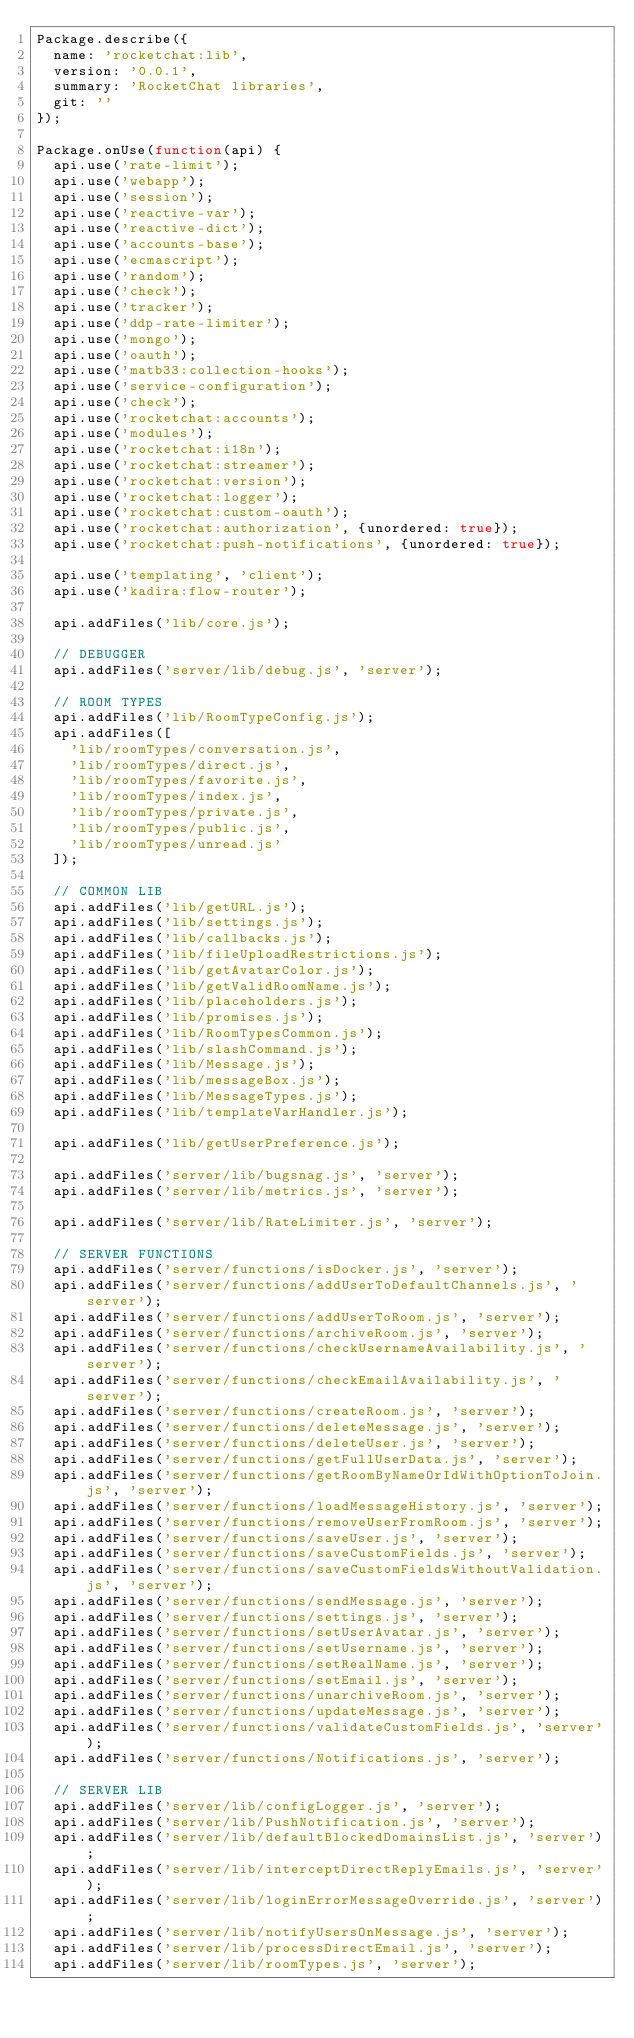Convert code to text. <code><loc_0><loc_0><loc_500><loc_500><_JavaScript_>Package.describe({
	name: 'rocketchat:lib',
	version: '0.0.1',
	summary: 'RocketChat libraries',
	git: ''
});

Package.onUse(function(api) {
	api.use('rate-limit');
	api.use('webapp');
	api.use('session');
	api.use('reactive-var');
	api.use('reactive-dict');
	api.use('accounts-base');
	api.use('ecmascript');
	api.use('random');
	api.use('check');
	api.use('tracker');
	api.use('ddp-rate-limiter');
	api.use('mongo');
	api.use('oauth');
	api.use('matb33:collection-hooks');
	api.use('service-configuration');
	api.use('check');
	api.use('rocketchat:accounts');
	api.use('modules');
	api.use('rocketchat:i18n');
	api.use('rocketchat:streamer');
	api.use('rocketchat:version');
	api.use('rocketchat:logger');
	api.use('rocketchat:custom-oauth');
	api.use('rocketchat:authorization', {unordered: true});
	api.use('rocketchat:push-notifications', {unordered: true});

	api.use('templating', 'client');
	api.use('kadira:flow-router');

	api.addFiles('lib/core.js');

	// DEBUGGER
	api.addFiles('server/lib/debug.js', 'server');

	// ROOM TYPES
	api.addFiles('lib/RoomTypeConfig.js');
	api.addFiles([
		'lib/roomTypes/conversation.js',
		'lib/roomTypes/direct.js',
		'lib/roomTypes/favorite.js',
		'lib/roomTypes/index.js',
		'lib/roomTypes/private.js',
		'lib/roomTypes/public.js',
		'lib/roomTypes/unread.js'
	]);

	// COMMON LIB
	api.addFiles('lib/getURL.js');
	api.addFiles('lib/settings.js');
	api.addFiles('lib/callbacks.js');
	api.addFiles('lib/fileUploadRestrictions.js');
	api.addFiles('lib/getAvatarColor.js');
	api.addFiles('lib/getValidRoomName.js');
	api.addFiles('lib/placeholders.js');
	api.addFiles('lib/promises.js');
	api.addFiles('lib/RoomTypesCommon.js');
	api.addFiles('lib/slashCommand.js');
	api.addFiles('lib/Message.js');
	api.addFiles('lib/messageBox.js');
	api.addFiles('lib/MessageTypes.js');
	api.addFiles('lib/templateVarHandler.js');

	api.addFiles('lib/getUserPreference.js');

	api.addFiles('server/lib/bugsnag.js', 'server');
	api.addFiles('server/lib/metrics.js', 'server');

	api.addFiles('server/lib/RateLimiter.js', 'server');

	// SERVER FUNCTIONS
	api.addFiles('server/functions/isDocker.js', 'server');
	api.addFiles('server/functions/addUserToDefaultChannels.js', 'server');
	api.addFiles('server/functions/addUserToRoom.js', 'server');
	api.addFiles('server/functions/archiveRoom.js', 'server');
	api.addFiles('server/functions/checkUsernameAvailability.js', 'server');
	api.addFiles('server/functions/checkEmailAvailability.js', 'server');
	api.addFiles('server/functions/createRoom.js', 'server');
	api.addFiles('server/functions/deleteMessage.js', 'server');
	api.addFiles('server/functions/deleteUser.js', 'server');
	api.addFiles('server/functions/getFullUserData.js', 'server');
	api.addFiles('server/functions/getRoomByNameOrIdWithOptionToJoin.js', 'server');
	api.addFiles('server/functions/loadMessageHistory.js', 'server');
	api.addFiles('server/functions/removeUserFromRoom.js', 'server');
	api.addFiles('server/functions/saveUser.js', 'server');
	api.addFiles('server/functions/saveCustomFields.js', 'server');
	api.addFiles('server/functions/saveCustomFieldsWithoutValidation.js', 'server');
	api.addFiles('server/functions/sendMessage.js', 'server');
	api.addFiles('server/functions/settings.js', 'server');
	api.addFiles('server/functions/setUserAvatar.js', 'server');
	api.addFiles('server/functions/setUsername.js', 'server');
	api.addFiles('server/functions/setRealName.js', 'server');
	api.addFiles('server/functions/setEmail.js', 'server');
	api.addFiles('server/functions/unarchiveRoom.js', 'server');
	api.addFiles('server/functions/updateMessage.js', 'server');
	api.addFiles('server/functions/validateCustomFields.js', 'server');
	api.addFiles('server/functions/Notifications.js', 'server');

	// SERVER LIB
	api.addFiles('server/lib/configLogger.js', 'server');
	api.addFiles('server/lib/PushNotification.js', 'server');
	api.addFiles('server/lib/defaultBlockedDomainsList.js', 'server');
	api.addFiles('server/lib/interceptDirectReplyEmails.js', 'server');
	api.addFiles('server/lib/loginErrorMessageOverride.js', 'server');
	api.addFiles('server/lib/notifyUsersOnMessage.js', 'server');
	api.addFiles('server/lib/processDirectEmail.js', 'server');
	api.addFiles('server/lib/roomTypes.js', 'server');</code> 